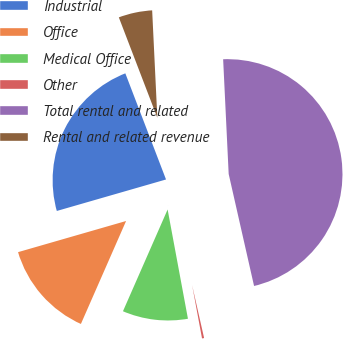Convert chart to OTSL. <chart><loc_0><loc_0><loc_500><loc_500><pie_chart><fcel>Industrial<fcel>Office<fcel>Medical Office<fcel>Other<fcel>Total rental and related<fcel>Rental and related revenue<nl><fcel>23.64%<fcel>13.95%<fcel>9.51%<fcel>0.62%<fcel>47.22%<fcel>5.06%<nl></chart> 